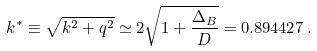<formula> <loc_0><loc_0><loc_500><loc_500>k ^ { * } \equiv \sqrt { k ^ { 2 } + q ^ { 2 } } \simeq 2 \sqrt { 1 + \frac { \Delta _ { B } } { D } } = 0 . 8 9 4 4 2 7 \, .</formula> 